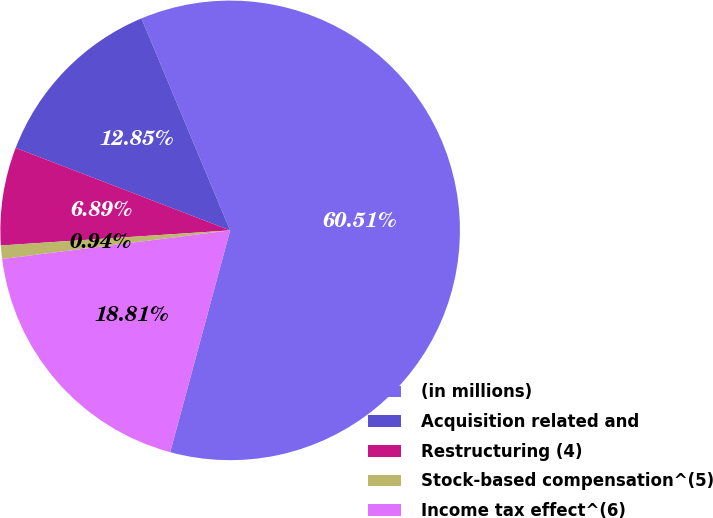Convert chart to OTSL. <chart><loc_0><loc_0><loc_500><loc_500><pie_chart><fcel>(in millions)<fcel>Acquisition related and<fcel>Restructuring (4)<fcel>Stock-based compensation^(5)<fcel>Income tax effect^(6)<nl><fcel>60.51%<fcel>12.85%<fcel>6.89%<fcel>0.94%<fcel>18.81%<nl></chart> 